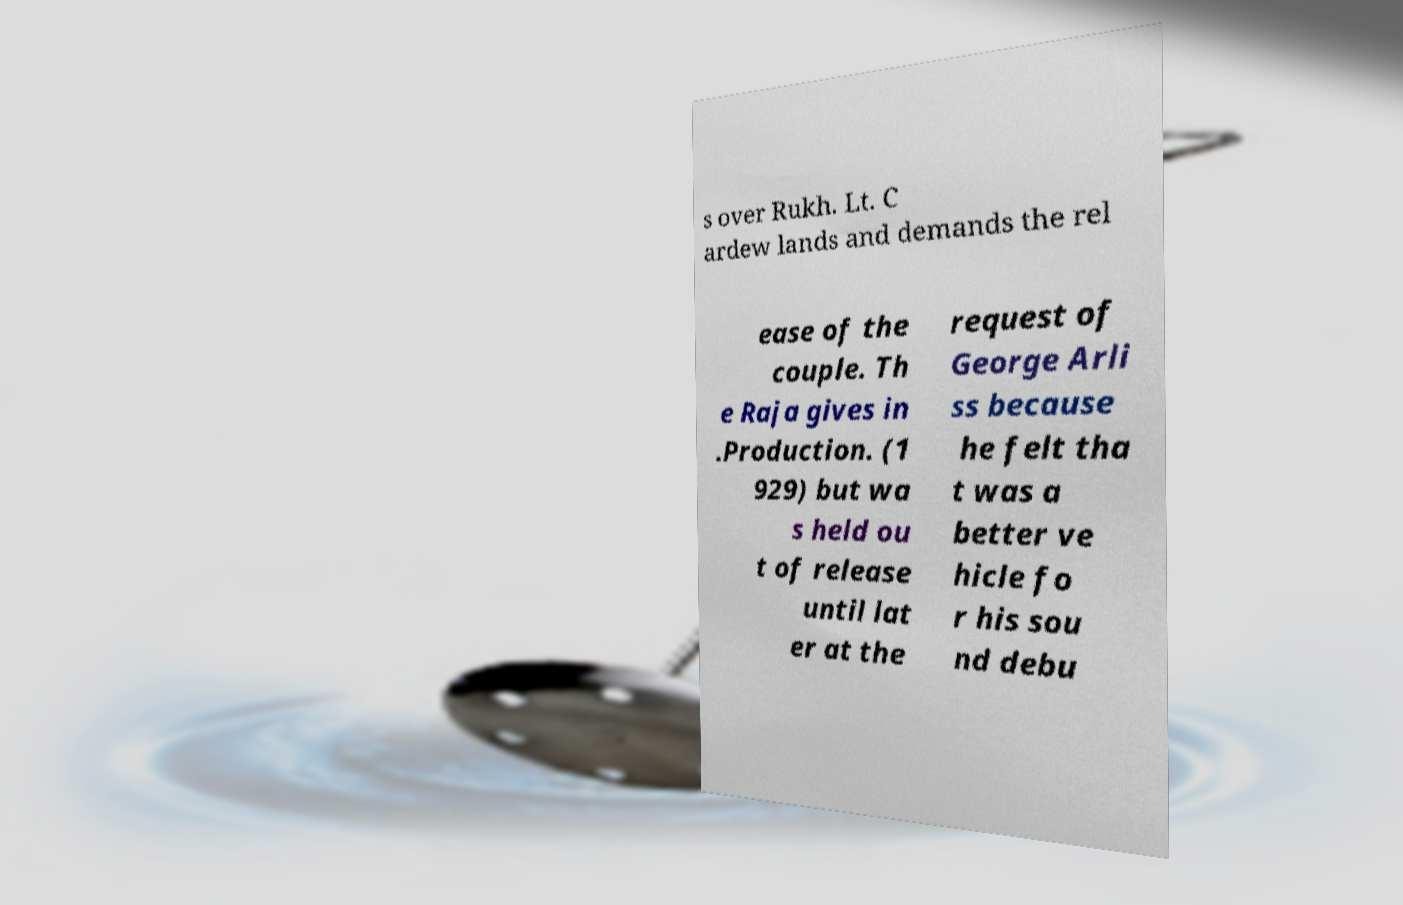Please identify and transcribe the text found in this image. s over Rukh. Lt. C ardew lands and demands the rel ease of the couple. Th e Raja gives in .Production. (1 929) but wa s held ou t of release until lat er at the request of George Arli ss because he felt tha t was a better ve hicle fo r his sou nd debu 